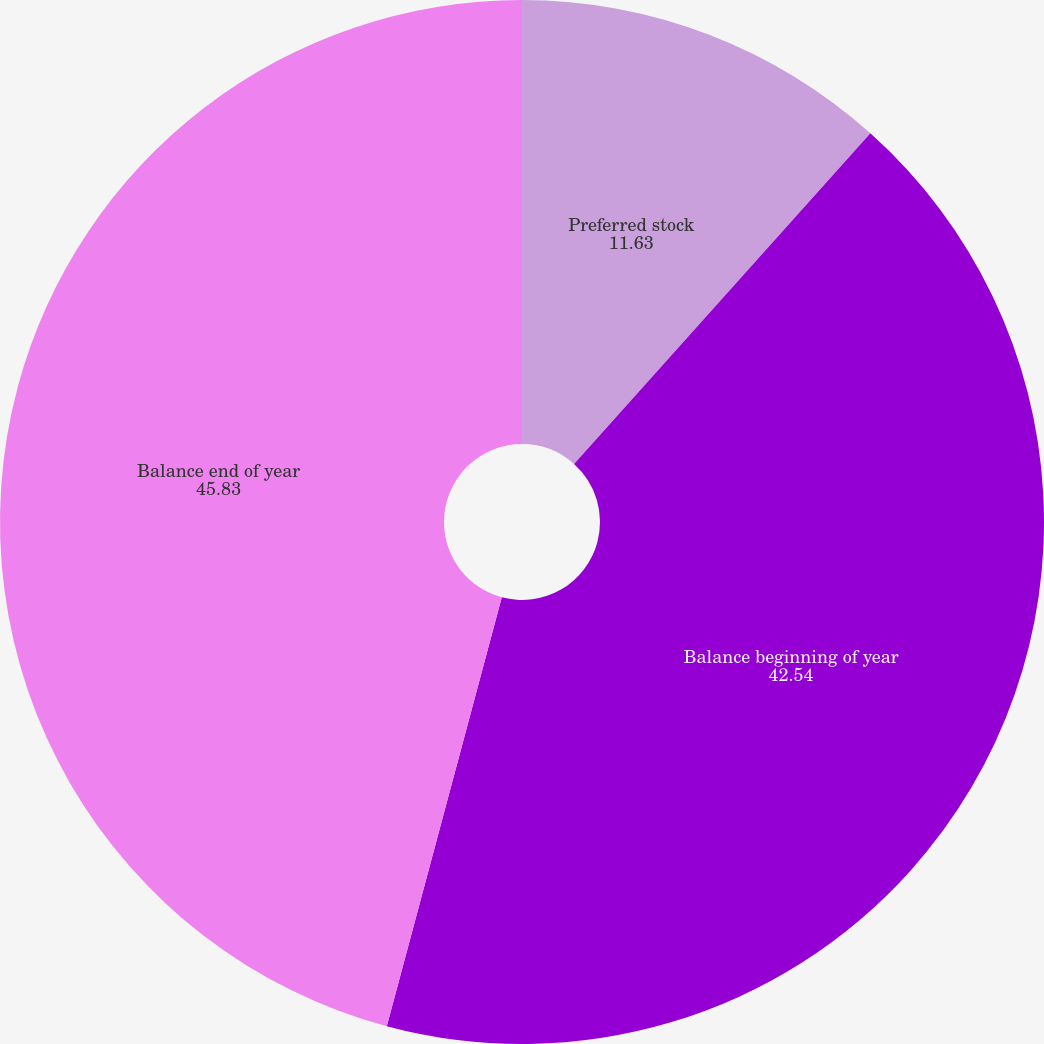Convert chart. <chart><loc_0><loc_0><loc_500><loc_500><pie_chart><fcel>Preferred stock<fcel>Balance beginning of year<fcel>Balance end of year<nl><fcel>11.63%<fcel>42.54%<fcel>45.83%<nl></chart> 